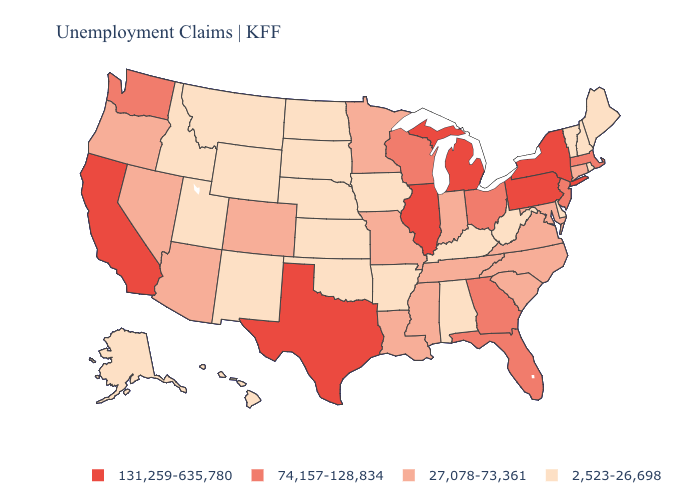Among the states that border New Mexico , which have the highest value?
Answer briefly. Texas. What is the highest value in the USA?
Answer briefly. 131,259-635,780. Does Oregon have the highest value in the USA?
Write a very short answer. No. What is the value of Missouri?
Write a very short answer. 27,078-73,361. Does West Virginia have the same value as Ohio?
Answer briefly. No. Does Montana have the lowest value in the West?
Write a very short answer. Yes. What is the value of West Virginia?
Be succinct. 2,523-26,698. Which states have the lowest value in the West?
Quick response, please. Alaska, Hawaii, Idaho, Montana, New Mexico, Utah, Wyoming. Name the states that have a value in the range 27,078-73,361?
Short answer required. Arizona, Colorado, Connecticut, Indiana, Louisiana, Maryland, Minnesota, Mississippi, Missouri, Nevada, North Carolina, Oregon, South Carolina, Tennessee, Virginia. What is the highest value in states that border Georgia?
Answer briefly. 74,157-128,834. Is the legend a continuous bar?
Write a very short answer. No. What is the highest value in the USA?
Be succinct. 131,259-635,780. What is the value of Massachusetts?
Be succinct. 74,157-128,834. Does New York have the lowest value in the Northeast?
Concise answer only. No. 